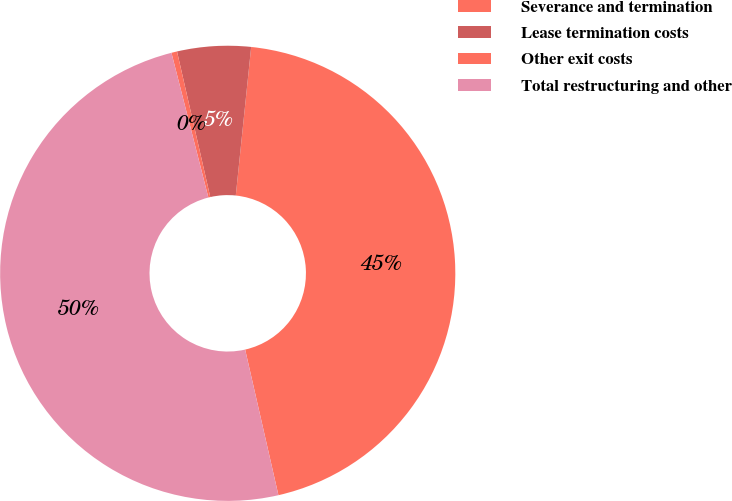Convert chart to OTSL. <chart><loc_0><loc_0><loc_500><loc_500><pie_chart><fcel>Severance and termination<fcel>Lease termination costs<fcel>Other exit costs<fcel>Total restructuring and other<nl><fcel>44.78%<fcel>5.22%<fcel>0.4%<fcel>49.6%<nl></chart> 